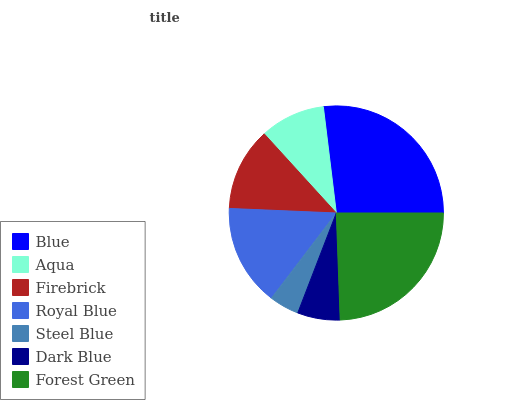Is Steel Blue the minimum?
Answer yes or no. Yes. Is Blue the maximum?
Answer yes or no. Yes. Is Aqua the minimum?
Answer yes or no. No. Is Aqua the maximum?
Answer yes or no. No. Is Blue greater than Aqua?
Answer yes or no. Yes. Is Aqua less than Blue?
Answer yes or no. Yes. Is Aqua greater than Blue?
Answer yes or no. No. Is Blue less than Aqua?
Answer yes or no. No. Is Firebrick the high median?
Answer yes or no. Yes. Is Firebrick the low median?
Answer yes or no. Yes. Is Forest Green the high median?
Answer yes or no. No. Is Steel Blue the low median?
Answer yes or no. No. 